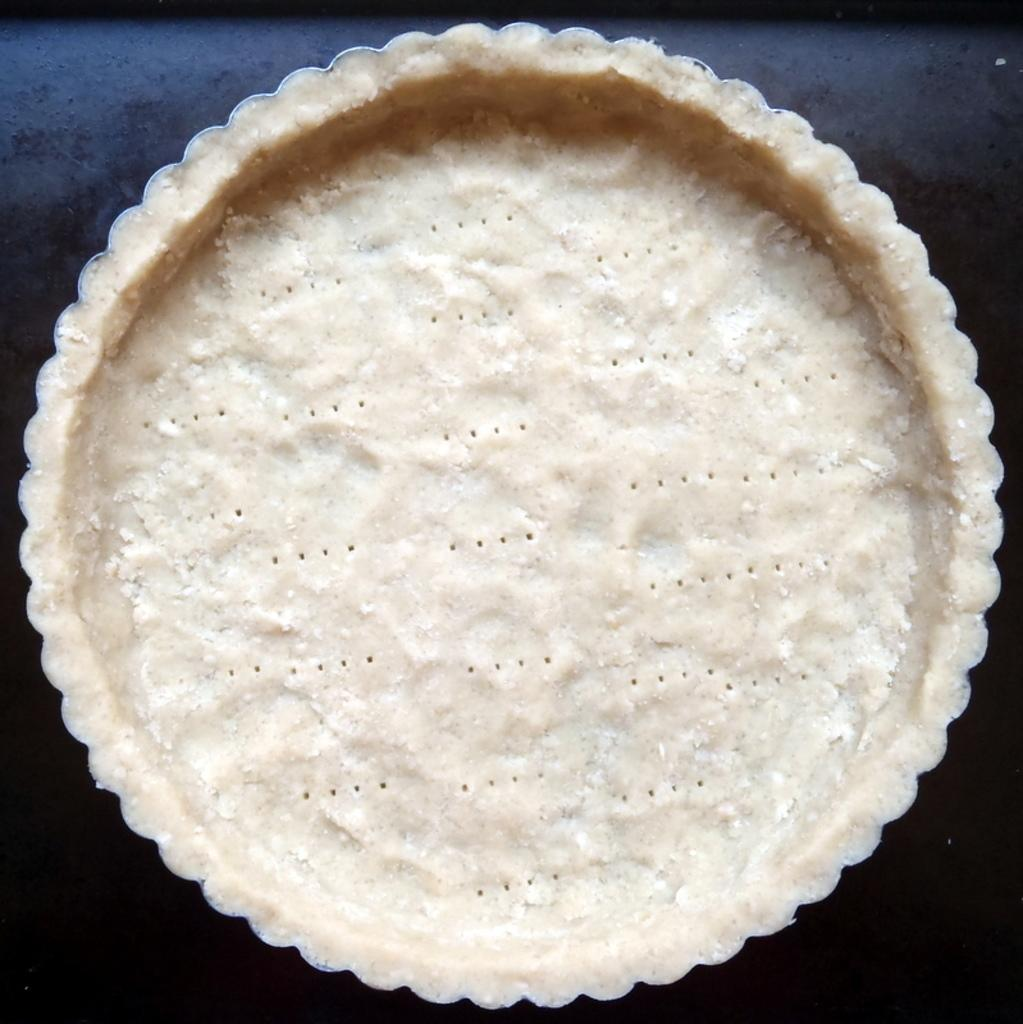What is the color of the main object in the image? The main object in the image is cream-colored. What color can be seen in the background of the image? Black color is visible in the background of the image. What type of hat is being worn by the person in the image? There is no person or hat present in the image; it only features a cream-colored object and black color in the background. 